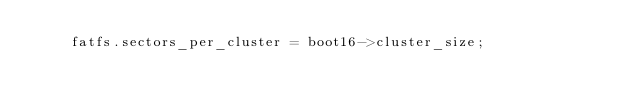Convert code to text. <code><loc_0><loc_0><loc_500><loc_500><_C_>    fatfs.sectors_per_cluster = boot16->cluster_size;</code> 